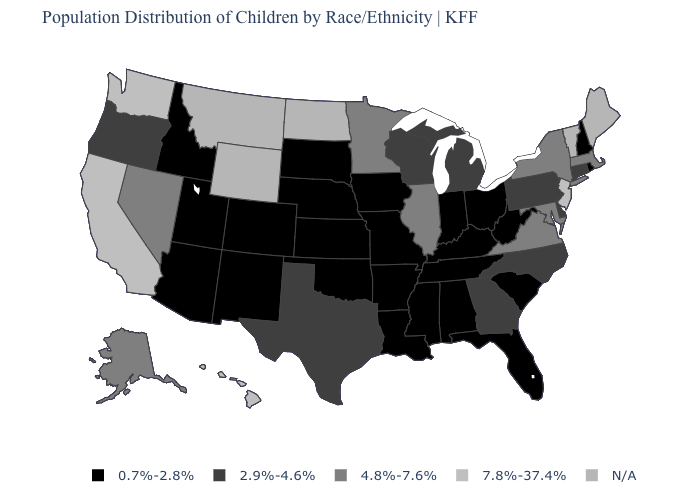What is the value of Nevada?
Be succinct. 4.8%-7.6%. Which states have the highest value in the USA?
Answer briefly. California, Hawaii, New Jersey, Washington. What is the value of Louisiana?
Be succinct. 0.7%-2.8%. What is the value of Indiana?
Quick response, please. 0.7%-2.8%. What is the value of Kansas?
Keep it brief. 0.7%-2.8%. What is the value of Massachusetts?
Quick response, please. 4.8%-7.6%. What is the value of Mississippi?
Keep it brief. 0.7%-2.8%. What is the lowest value in the Northeast?
Give a very brief answer. 0.7%-2.8%. Name the states that have a value in the range 2.9%-4.6%?
Be succinct. Connecticut, Delaware, Georgia, Michigan, North Carolina, Oregon, Pennsylvania, Texas, Wisconsin. Name the states that have a value in the range 2.9%-4.6%?
Concise answer only. Connecticut, Delaware, Georgia, Michigan, North Carolina, Oregon, Pennsylvania, Texas, Wisconsin. What is the value of Hawaii?
Give a very brief answer. 7.8%-37.4%. Does Pennsylvania have the lowest value in the USA?
Concise answer only. No. What is the value of Minnesota?
Short answer required. 4.8%-7.6%. 